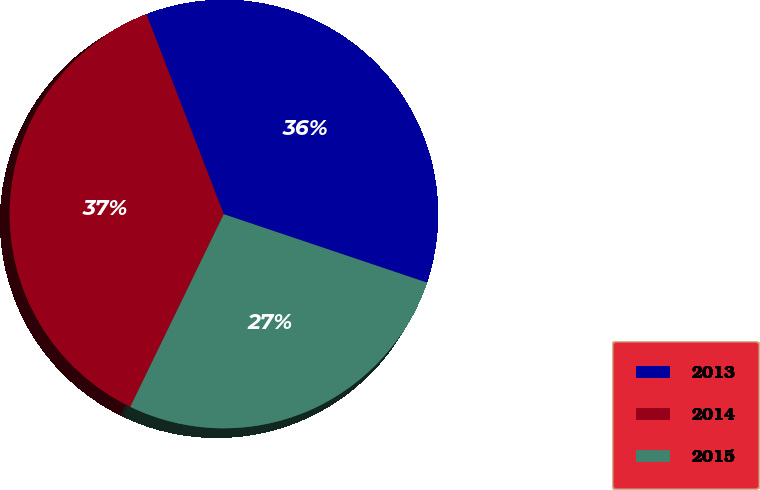<chart> <loc_0><loc_0><loc_500><loc_500><pie_chart><fcel>2013<fcel>2014<fcel>2015<nl><fcel>36.04%<fcel>36.94%<fcel>27.02%<nl></chart> 